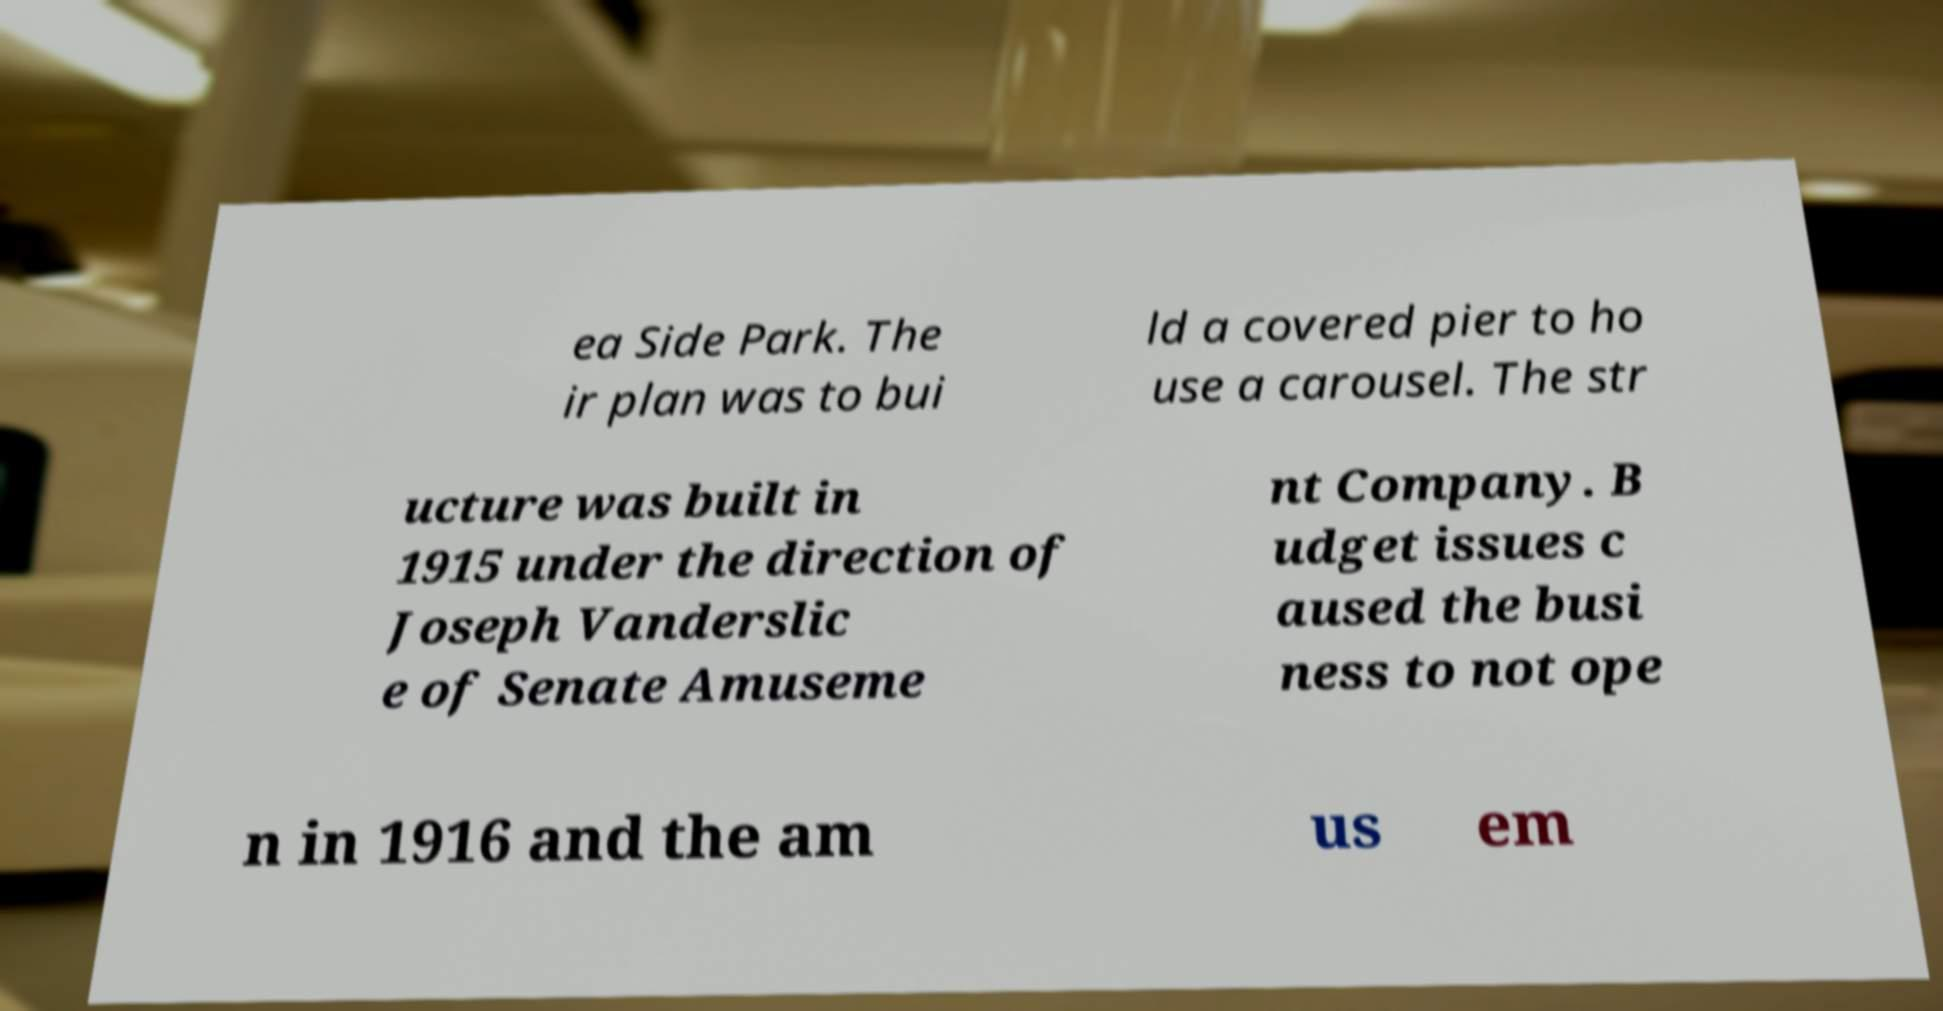What messages or text are displayed in this image? I need them in a readable, typed format. ea Side Park. The ir plan was to bui ld a covered pier to ho use a carousel. The str ucture was built in 1915 under the direction of Joseph Vanderslic e of Senate Amuseme nt Company. B udget issues c aused the busi ness to not ope n in 1916 and the am us em 